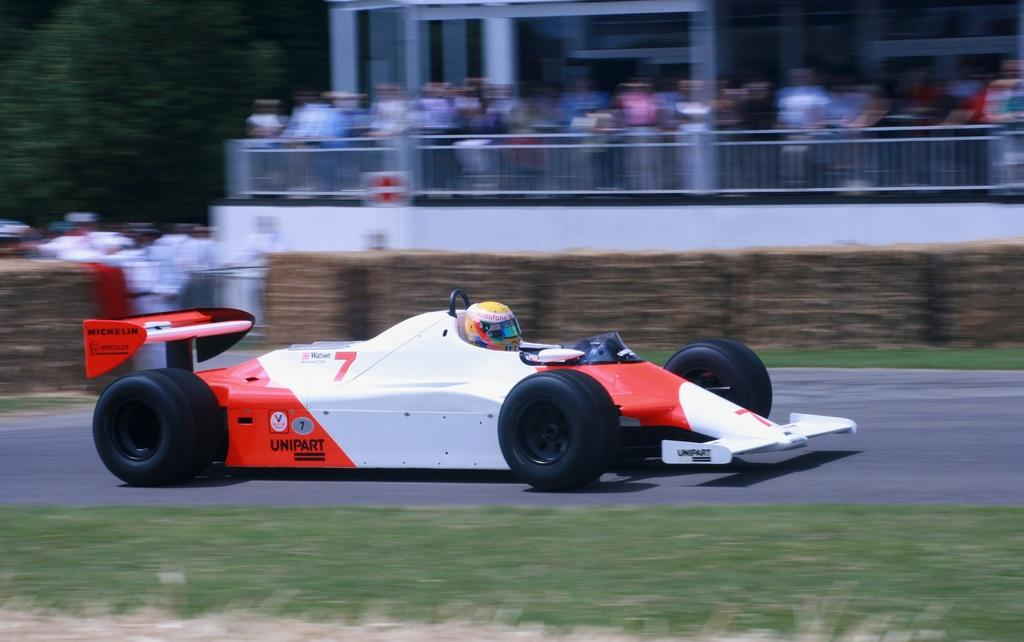What is the main subject of the image? The main subject of the image is a car on the road. What can be seen in the background of the image? There is a fencing and a crowd in the background of the image. What type of idea is being discussed by the rabbit in the image? There is no rabbit present in the image, so it is not possible to determine what idea might be discussed. 